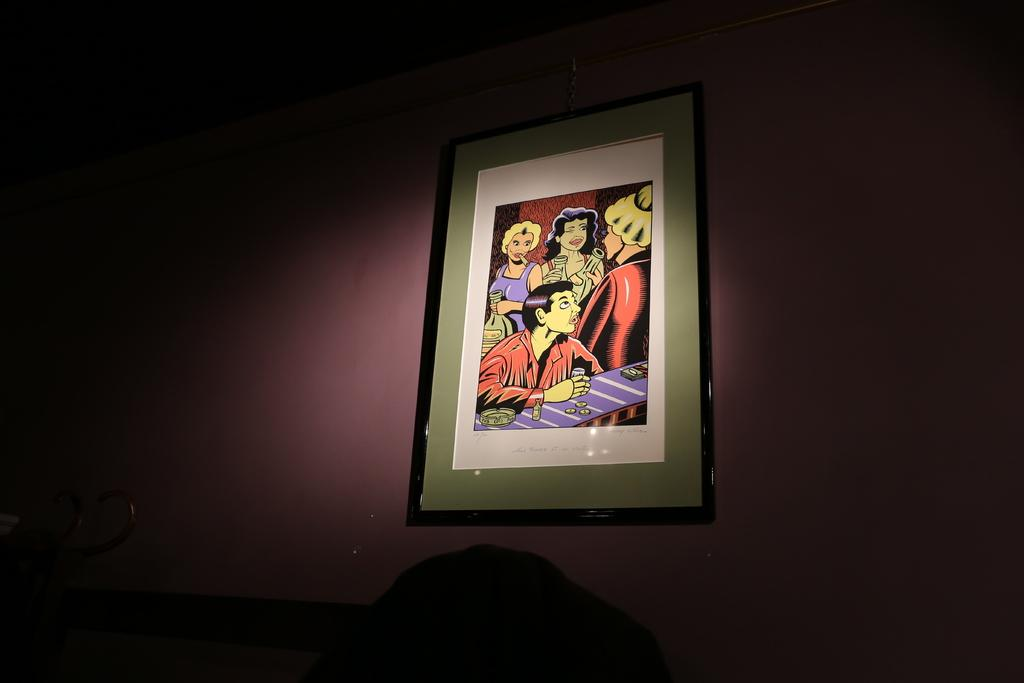What object can be seen in the image that typically holds a picture? There is a picture frame in the image. Where is the picture frame located? The picture frame is on the wall. What type of pancake is being served at the airport in the image? There is no airport or pancake present in the image; it only features a picture frame on the wall. 